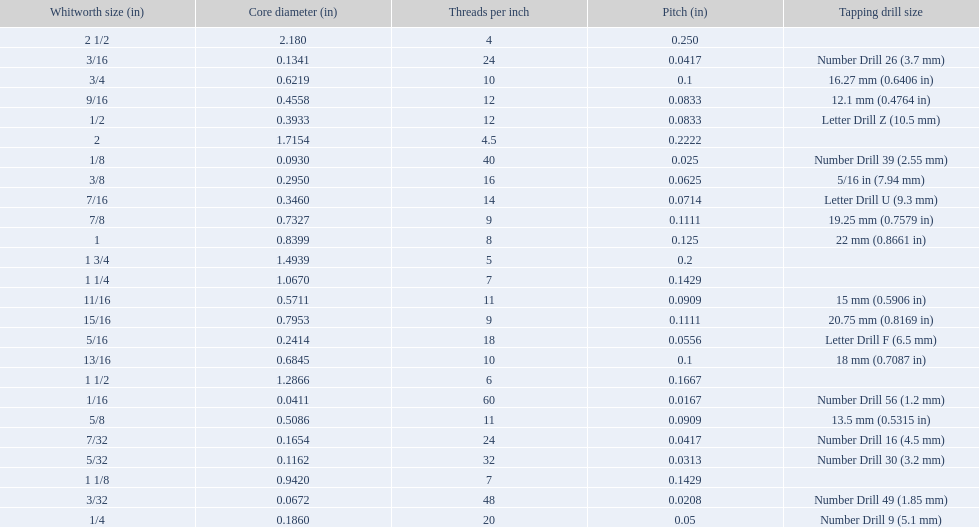What are all of the whitworth sizes? 1/16, 3/32, 1/8, 5/32, 3/16, 7/32, 1/4, 5/16, 3/8, 7/16, 1/2, 9/16, 5/8, 11/16, 3/4, 13/16, 7/8, 15/16, 1, 1 1/8, 1 1/4, 1 1/2, 1 3/4, 2, 2 1/2. How many threads per inch are in each size? 60, 48, 40, 32, 24, 24, 20, 18, 16, 14, 12, 12, 11, 11, 10, 10, 9, 9, 8, 7, 7, 6, 5, 4.5, 4. How many threads per inch are in the 3/16 size? 24. And which other size has the same number of threads? 7/32. 